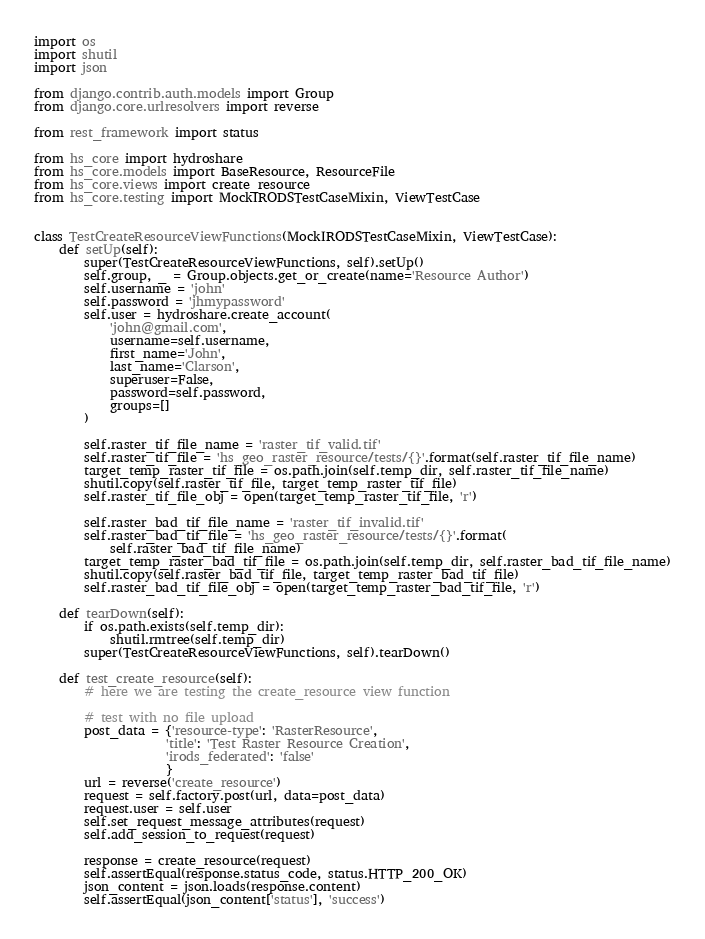Convert code to text. <code><loc_0><loc_0><loc_500><loc_500><_Python_>import os
import shutil
import json

from django.contrib.auth.models import Group
from django.core.urlresolvers import reverse

from rest_framework import status

from hs_core import hydroshare
from hs_core.models import BaseResource, ResourceFile
from hs_core.views import create_resource
from hs_core.testing import MockIRODSTestCaseMixin, ViewTestCase


class TestCreateResourceViewFunctions(MockIRODSTestCaseMixin, ViewTestCase):
    def setUp(self):
        super(TestCreateResourceViewFunctions, self).setUp()
        self.group, _ = Group.objects.get_or_create(name='Resource Author')
        self.username = 'john'
        self.password = 'jhmypassword'
        self.user = hydroshare.create_account(
            'john@gmail.com',
            username=self.username,
            first_name='John',
            last_name='Clarson',
            superuser=False,
            password=self.password,
            groups=[]
        )

        self.raster_tif_file_name = 'raster_tif_valid.tif'
        self.raster_tif_file = 'hs_geo_raster_resource/tests/{}'.format(self.raster_tif_file_name)
        target_temp_raster_tif_file = os.path.join(self.temp_dir, self.raster_tif_file_name)
        shutil.copy(self.raster_tif_file, target_temp_raster_tif_file)
        self.raster_tif_file_obj = open(target_temp_raster_tif_file, 'r')

        self.raster_bad_tif_file_name = 'raster_tif_invalid.tif'
        self.raster_bad_tif_file = 'hs_geo_raster_resource/tests/{}'.format(
            self.raster_bad_tif_file_name)
        target_temp_raster_bad_tif_file = os.path.join(self.temp_dir, self.raster_bad_tif_file_name)
        shutil.copy(self.raster_bad_tif_file, target_temp_raster_bad_tif_file)
        self.raster_bad_tif_file_obj = open(target_temp_raster_bad_tif_file, 'r')

    def tearDown(self):
        if os.path.exists(self.temp_dir):
            shutil.rmtree(self.temp_dir)
        super(TestCreateResourceViewFunctions, self).tearDown()

    def test_create_resource(self):
        # here we are testing the create_resource view function

        # test with no file upload
        post_data = {'resource-type': 'RasterResource',
                     'title': 'Test Raster Resource Creation',
                     'irods_federated': 'false'
                     }
        url = reverse('create_resource')
        request = self.factory.post(url, data=post_data)
        request.user = self.user
        self.set_request_message_attributes(request)
        self.add_session_to_request(request)

        response = create_resource(request)
        self.assertEqual(response.status_code, status.HTTP_200_OK)
        json_content = json.loads(response.content)
        self.assertEqual(json_content['status'], 'success')</code> 